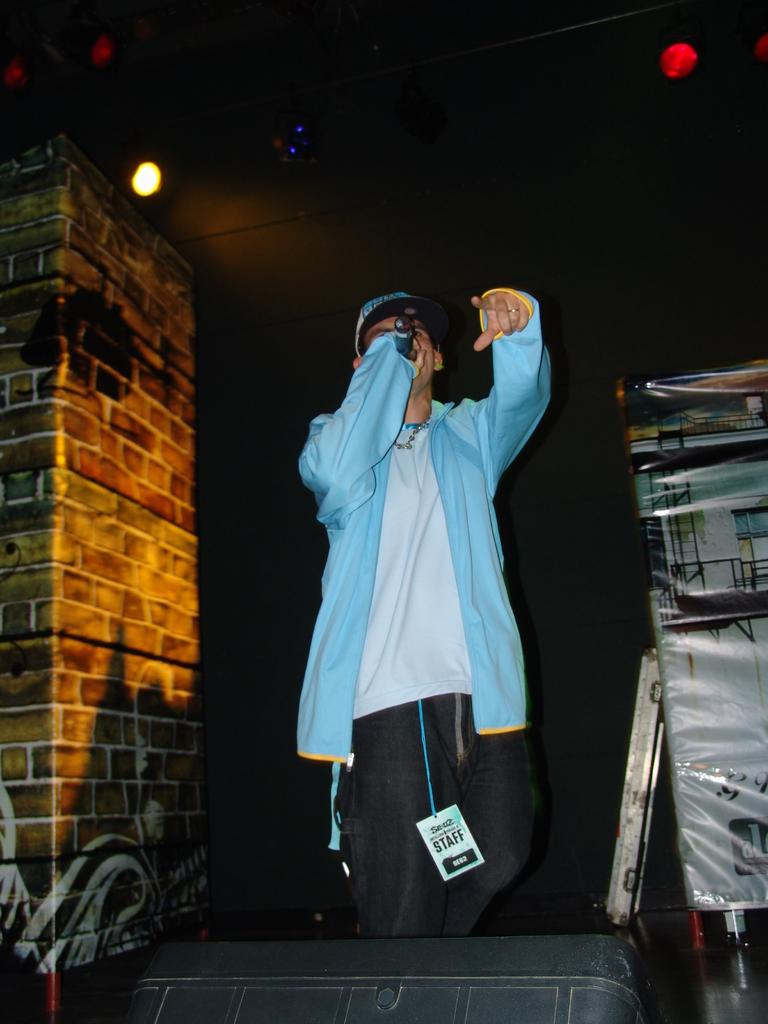What is the person in the image doing? The person is standing and holding a mic. What can be seen in the background of the image? There is a pillar and lights visible in the background of the image. How would you describe the lighting in the image? The background of the image is dark. What is in front of the person in the image? There are objects visible in front of the person. What type of teeth can be seen in the image? There are no teeth visible in the image. What is the plot of the story being told in the image? The image does not depict a story or plot; it shows a person holding a mic. 